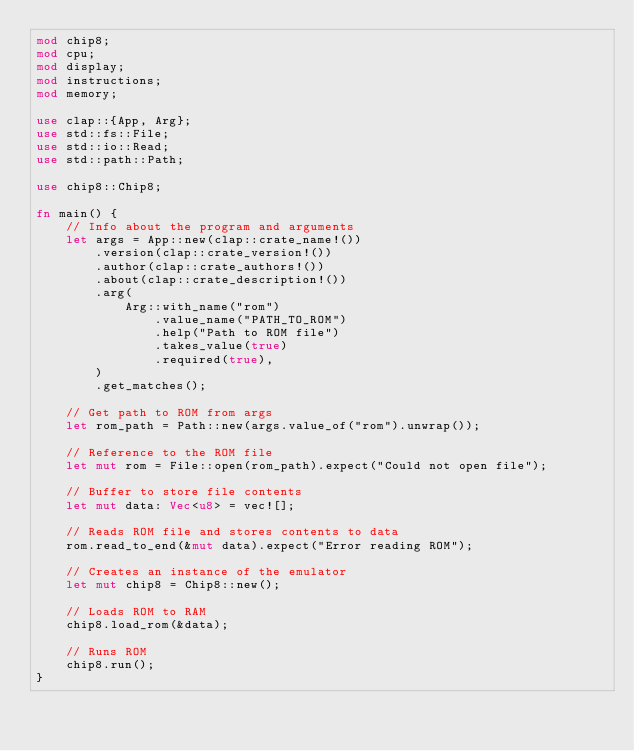<code> <loc_0><loc_0><loc_500><loc_500><_Rust_>mod chip8;
mod cpu;
mod display;
mod instructions;
mod memory;

use clap::{App, Arg};
use std::fs::File;
use std::io::Read;
use std::path::Path;

use chip8::Chip8;

fn main() {
    // Info about the program and arguments
    let args = App::new(clap::crate_name!())
        .version(clap::crate_version!())
        .author(clap::crate_authors!())
        .about(clap::crate_description!())
        .arg(
            Arg::with_name("rom")
                .value_name("PATH_TO_ROM")
                .help("Path to ROM file")
                .takes_value(true)
                .required(true),
        )
        .get_matches();

    // Get path to ROM from args
    let rom_path = Path::new(args.value_of("rom").unwrap());

    // Reference to the ROM file
    let mut rom = File::open(rom_path).expect("Could not open file");

    // Buffer to store file contents
    let mut data: Vec<u8> = vec![];

    // Reads ROM file and stores contents to data
    rom.read_to_end(&mut data).expect("Error reading ROM");

    // Creates an instance of the emulator
    let mut chip8 = Chip8::new();

    // Loads ROM to RAM
    chip8.load_rom(&data);

    // Runs ROM
    chip8.run();
}
</code> 